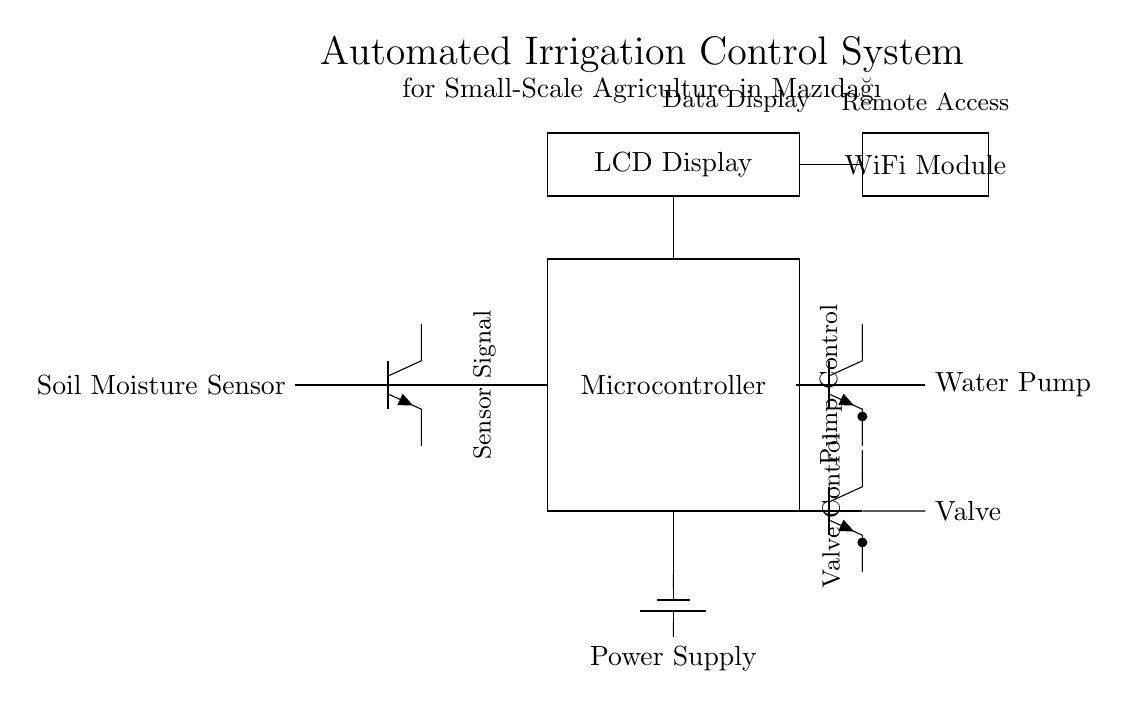What is the main component controlling the irrigation system? The main component controlling the irrigation system is the microcontroller, which manages signals from the soil moisture sensor and controls the water pump and valve.
Answer: Microcontroller What signals the need for irrigation? The soil moisture sensor detects the moisture level in the soil, indicating whether irrigation is needed based on its readings.
Answer: Soil moisture sensor How does the water pump receive control signals? The microcontroller sends a control signal to the water pump, activating it when irrigation is required according to the moisture sensor's input.
Answer: Water pump control signal What display shows information about the irrigation system? The system includes an LCD display, which shows relevant data regarding the irrigation status and sensor readings.
Answer: LCD display Which component allows remote access to the irrigation system? The WiFi module enables remote access, allowing users to control and monitor the irrigation system from a distance.
Answer: WiFi module What is the role of the valve in the irrigation system? The valve controls the flow of water from the pump to the irrigation system, opening or closing as directed by the microcontroller.
Answer: Valve How is the irrigation system powered? The system is powered by a battery, supplying the necessary energy for all components, including the microcontroller and water pump.
Answer: Power supply 